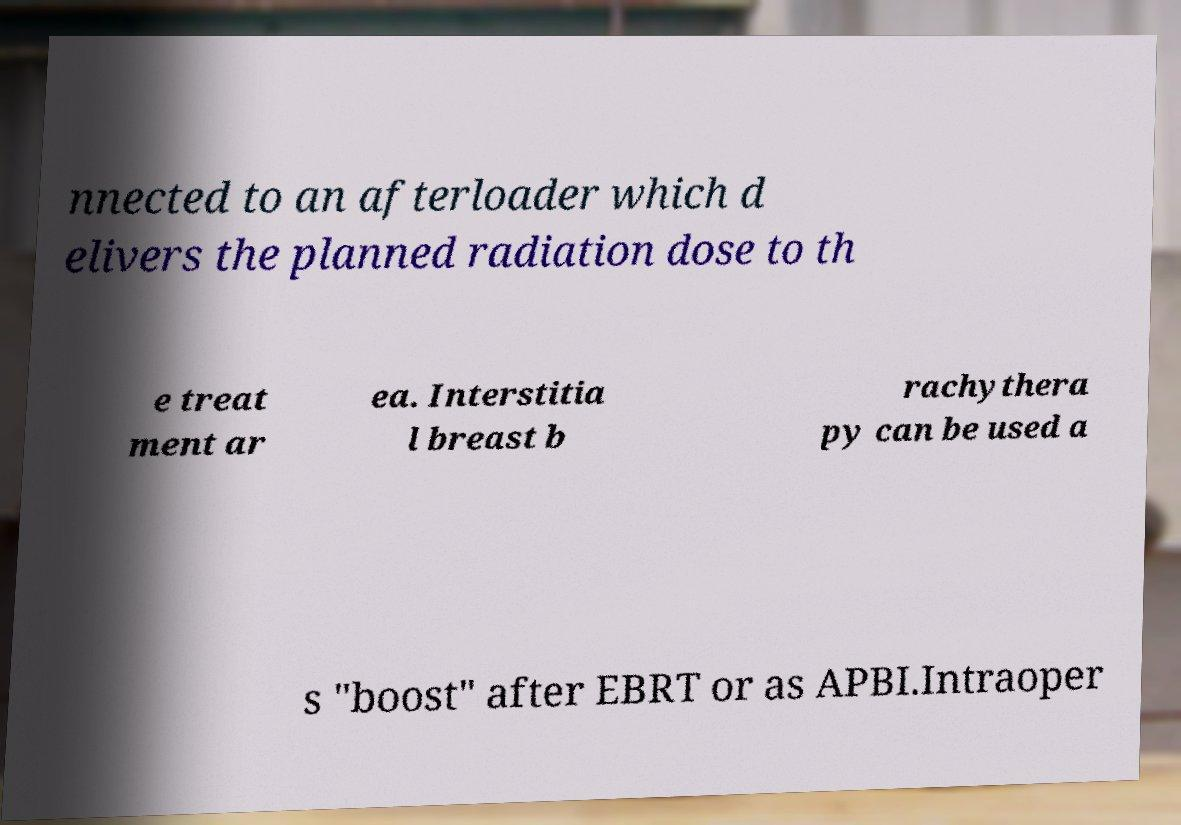Please identify and transcribe the text found in this image. nnected to an afterloader which d elivers the planned radiation dose to th e treat ment ar ea. Interstitia l breast b rachythera py can be used a s "boost" after EBRT or as APBI.Intraoper 